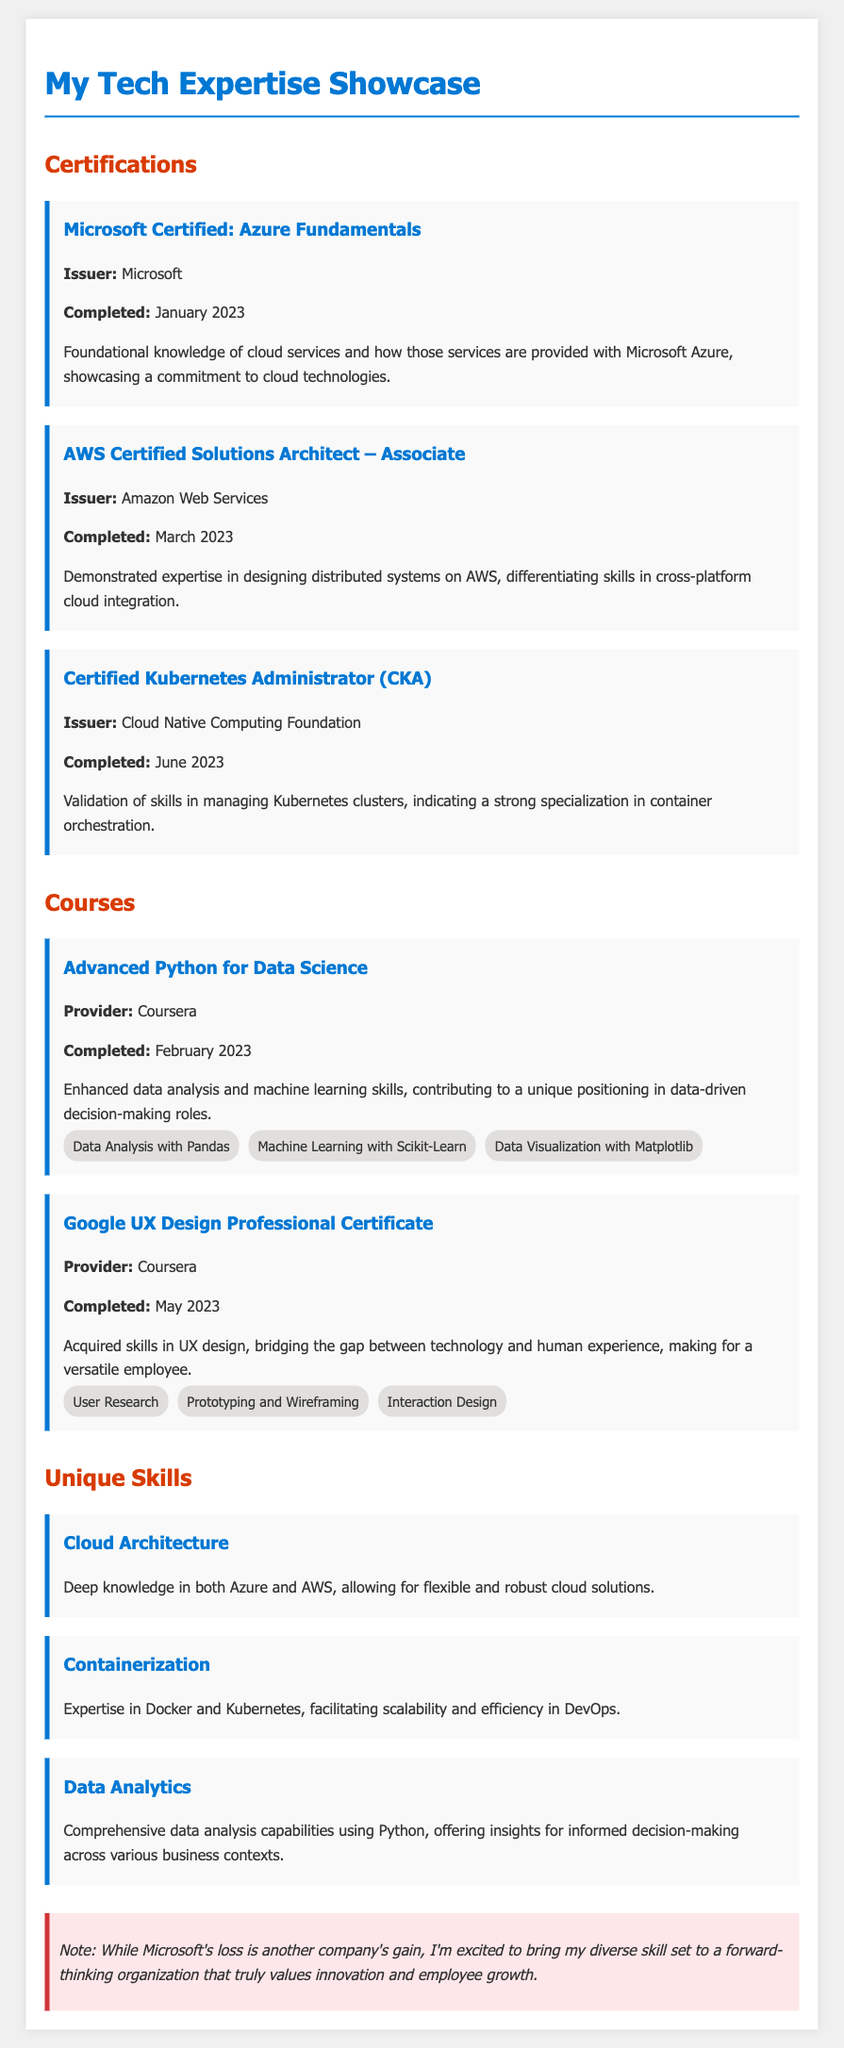What is the first certification listed in the document? The first certification mentioned is "Microsoft Certified: Azure Fundamentals."
Answer: Microsoft Certified: Azure Fundamentals When was the AWS Certified Solutions Architect completed? The completion date for the AWS Certified Solutions Architect is March 2023.
Answer: March 2023 Which course provides skills in UX design? The course that provides skills in UX design is "Google UX Design Professional Certificate."
Answer: Google UX Design Professional Certificate What two cloud platforms does the individual have deep knowledge in? The individual has deep knowledge in both Azure and AWS platforms.
Answer: Azure and AWS What skill is associated with the "Certified Kubernetes Administrator"? The skill associated with the Certified Kubernetes Administrator is managing Kubernetes clusters.
Answer: Managing Kubernetes clusters Which organization issued the Certified Kubernetes Administrator certification? The certification was issued by the Cloud Native Computing Foundation.
Answer: Cloud Native Computing Foundation How many skills are listed under the "Advanced Python for Data Science" course? There are three skills listed under the Advanced Python for Data Science course.
Answer: Three skills What is the unique skill covering scalability and efficiency in DevOps? The unique skill covering this area is "Containerization."
Answer: Containerization What is noted in the bitterness section of the document? The note in this section expresses excitement to bring skills to a forward-thinking organization.
Answer: Excitement to bring skills to a forward-thinking organization 